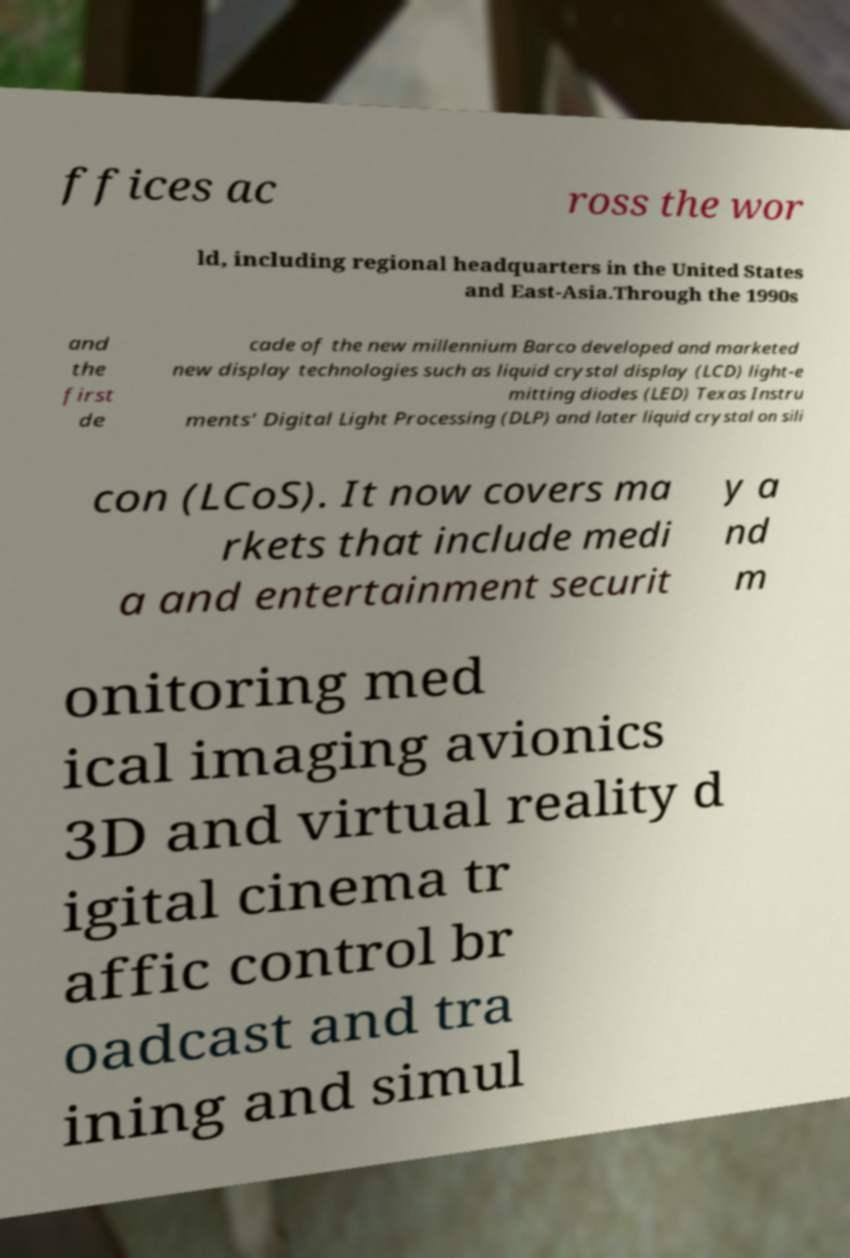Could you extract and type out the text from this image? ffices ac ross the wor ld, including regional headquarters in the United States and East-Asia.Through the 1990s and the first de cade of the new millennium Barco developed and marketed new display technologies such as liquid crystal display (LCD) light-e mitting diodes (LED) Texas Instru ments' Digital Light Processing (DLP) and later liquid crystal on sili con (LCoS). It now covers ma rkets that include medi a and entertainment securit y a nd m onitoring med ical imaging avionics 3D and virtual reality d igital cinema tr affic control br oadcast and tra ining and simul 